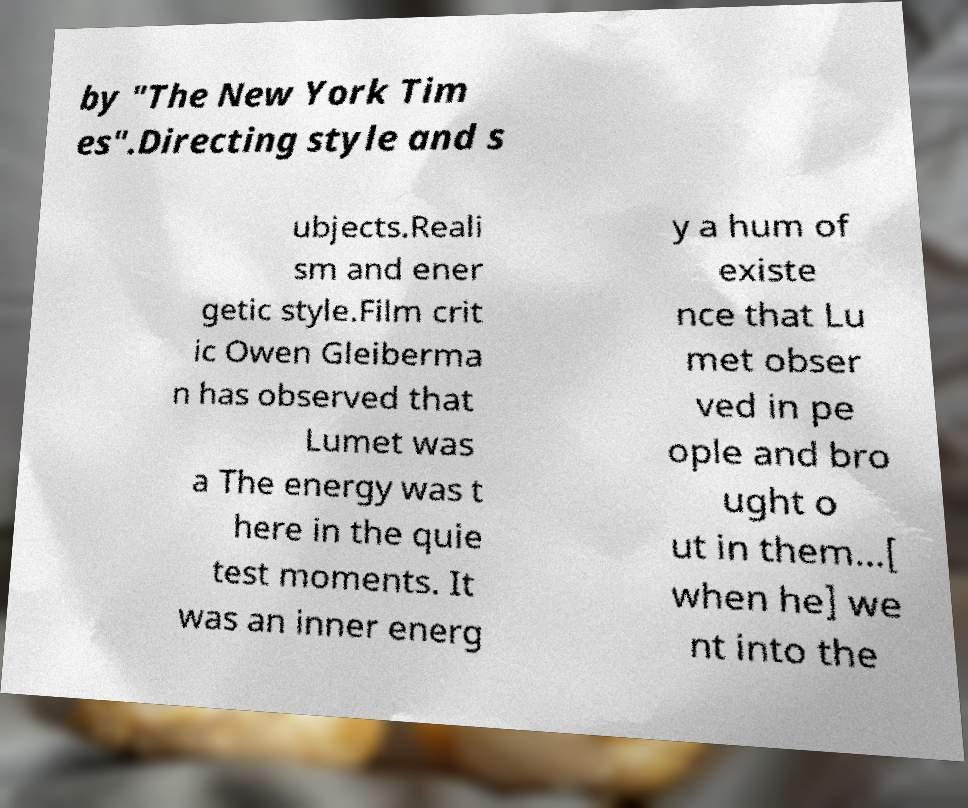Could you assist in decoding the text presented in this image and type it out clearly? by "The New York Tim es".Directing style and s ubjects.Reali sm and ener getic style.Film crit ic Owen Gleiberma n has observed that Lumet was a The energy was t here in the quie test moments. It was an inner energ y a hum of existe nce that Lu met obser ved in pe ople and bro ught o ut in them...[ when he] we nt into the 